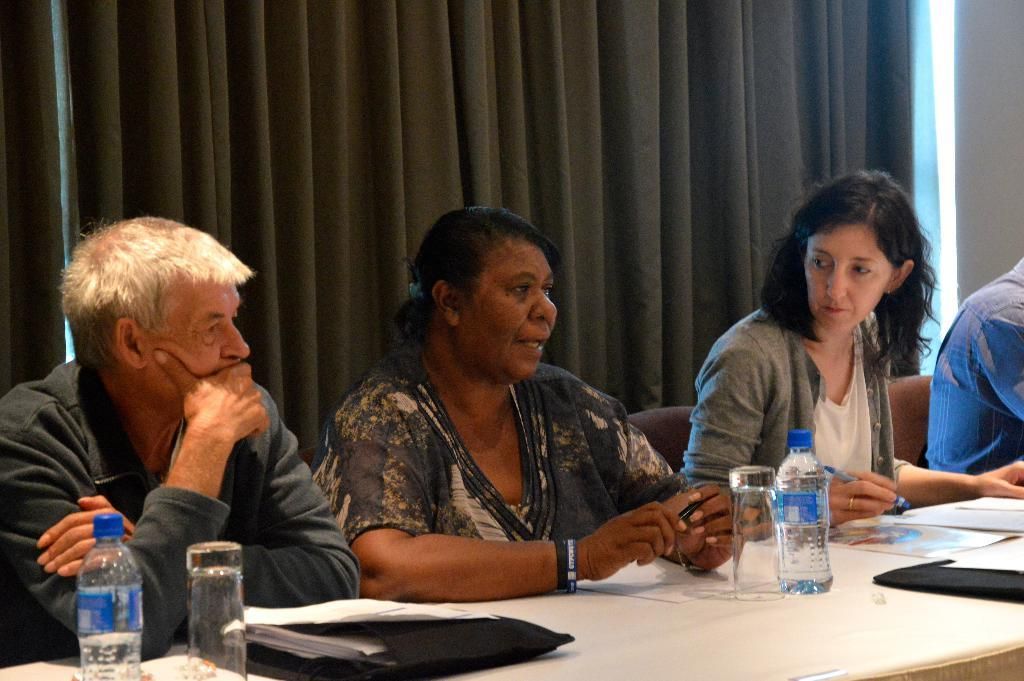How many people are sitting in the chair in the image? There is a group of persons sitting in a chair in the image. What is in front of the people sitting in the chair? There is a table in front of them. What can be seen on the table in the image? The table has papers, water bottles, and glasses on it. What is visible in the background of the image? There is a grey curtain in the background. What type of thought can be seen floating above the table in the image? There is no thought visible in the image; it is a group of persons sitting in a chair with a table in front of them. What type of soda is being served in the glasses on the table? The image does not specify the type of liquid in the glasses; they are simply described as glasses on the table. 